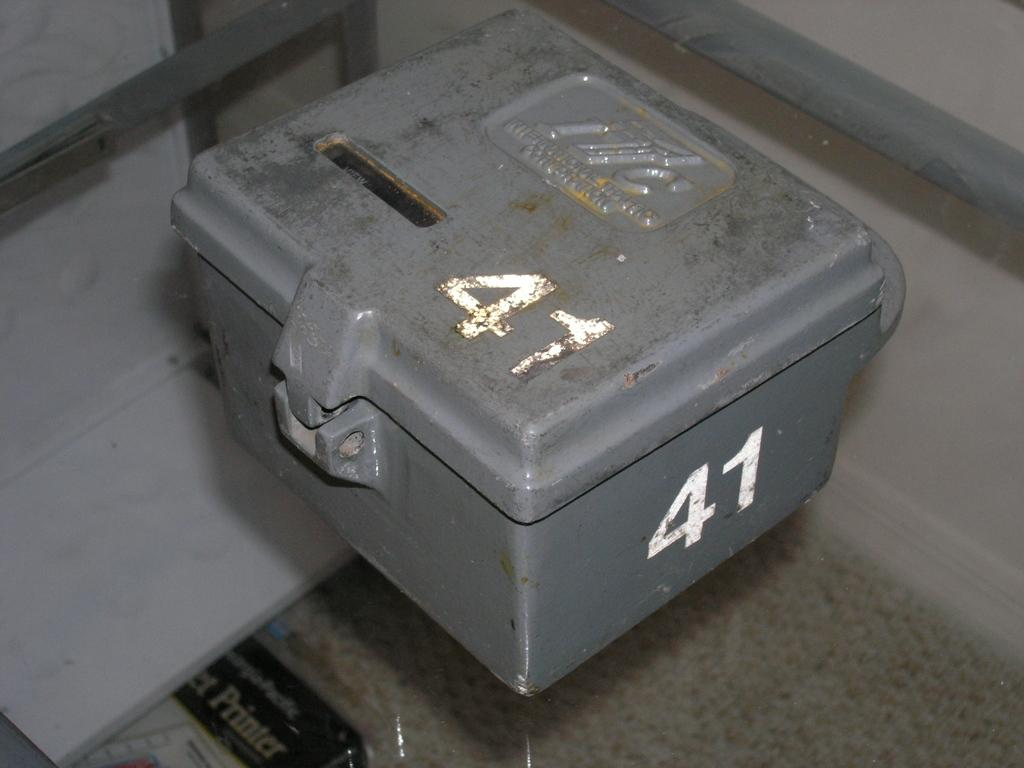<image>
Write a terse but informative summary of the picture. A gray lock box with the number 41 on it 